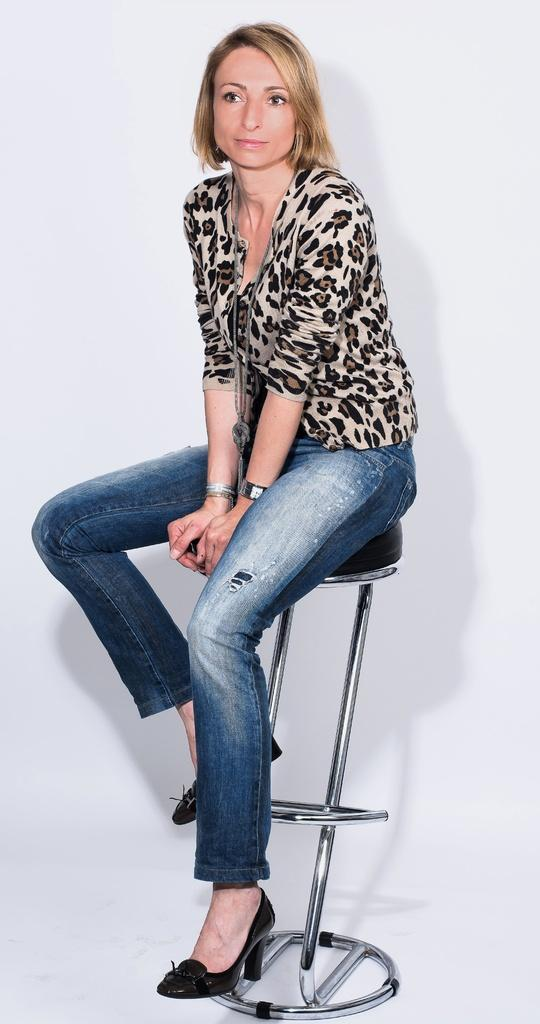Who is the main subject in the image? There is a woman in the image. What is the woman wearing? The woman is wearing a top and jeans. What is the woman doing in the image? The woman is sitting on a chair and posing for the camera. What is the color of the background in the image? The background in the image is white. Can you see a donkey in the image? No, there is no donkey present in the image. What type of stretch is the woman doing in the image? The woman is not stretching in the image; she is sitting on a chair and posing for the camera. 